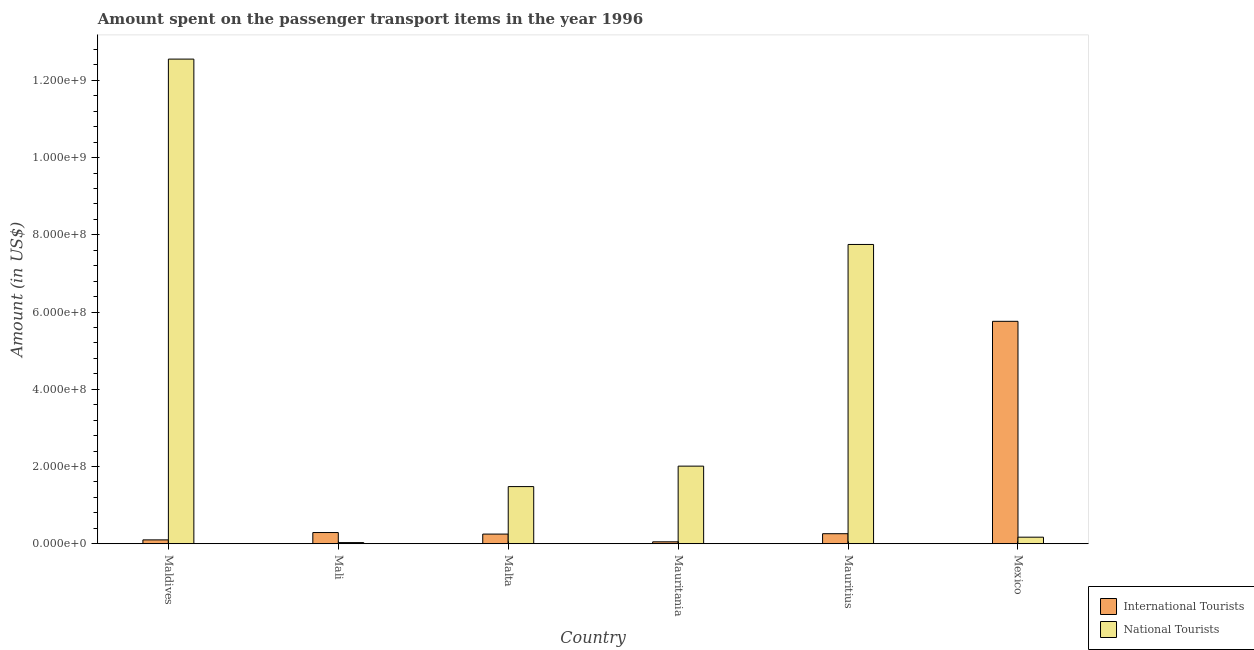How many bars are there on the 5th tick from the left?
Give a very brief answer. 2. How many bars are there on the 6th tick from the right?
Provide a succinct answer. 2. In how many cases, is the number of bars for a given country not equal to the number of legend labels?
Give a very brief answer. 0. What is the amount spent on transport items of international tourists in Mexico?
Your answer should be compact. 5.76e+08. Across all countries, what is the maximum amount spent on transport items of international tourists?
Provide a succinct answer. 5.76e+08. In which country was the amount spent on transport items of international tourists maximum?
Your response must be concise. Mexico. In which country was the amount spent on transport items of national tourists minimum?
Ensure brevity in your answer.  Mali. What is the total amount spent on transport items of international tourists in the graph?
Your response must be concise. 6.71e+08. What is the difference between the amount spent on transport items of national tourists in Maldives and that in Malta?
Provide a short and direct response. 1.11e+09. What is the difference between the amount spent on transport items of international tourists in Maldives and the amount spent on transport items of national tourists in Mauritius?
Keep it short and to the point. -7.65e+08. What is the average amount spent on transport items of international tourists per country?
Offer a very short reply. 1.12e+08. What is the difference between the amount spent on transport items of national tourists and amount spent on transport items of international tourists in Malta?
Make the answer very short. 1.23e+08. In how many countries, is the amount spent on transport items of international tourists greater than 200000000 US$?
Provide a succinct answer. 1. What is the ratio of the amount spent on transport items of international tourists in Maldives to that in Mexico?
Offer a terse response. 0.02. What is the difference between the highest and the second highest amount spent on transport items of national tourists?
Keep it short and to the point. 4.80e+08. What is the difference between the highest and the lowest amount spent on transport items of national tourists?
Offer a terse response. 1.25e+09. In how many countries, is the amount spent on transport items of national tourists greater than the average amount spent on transport items of national tourists taken over all countries?
Keep it short and to the point. 2. Is the sum of the amount spent on transport items of international tourists in Mali and Mexico greater than the maximum amount spent on transport items of national tourists across all countries?
Ensure brevity in your answer.  No. What does the 1st bar from the left in Mexico represents?
Ensure brevity in your answer.  International Tourists. What does the 1st bar from the right in Mauritania represents?
Give a very brief answer. National Tourists. How many bars are there?
Your response must be concise. 12. Are all the bars in the graph horizontal?
Ensure brevity in your answer.  No. How many countries are there in the graph?
Provide a short and direct response. 6. What is the difference between two consecutive major ticks on the Y-axis?
Your response must be concise. 2.00e+08. What is the title of the graph?
Provide a short and direct response. Amount spent on the passenger transport items in the year 1996. Does "Transport services" appear as one of the legend labels in the graph?
Ensure brevity in your answer.  No. What is the label or title of the X-axis?
Your answer should be very brief. Country. What is the Amount (in US$) of International Tourists in Maldives?
Keep it short and to the point. 1.00e+07. What is the Amount (in US$) in National Tourists in Maldives?
Your answer should be compact. 1.26e+09. What is the Amount (in US$) in International Tourists in Mali?
Your answer should be compact. 2.90e+07. What is the Amount (in US$) of National Tourists in Mali?
Give a very brief answer. 3.00e+06. What is the Amount (in US$) of International Tourists in Malta?
Make the answer very short. 2.50e+07. What is the Amount (in US$) of National Tourists in Malta?
Provide a short and direct response. 1.48e+08. What is the Amount (in US$) of National Tourists in Mauritania?
Your answer should be very brief. 2.01e+08. What is the Amount (in US$) of International Tourists in Mauritius?
Offer a very short reply. 2.60e+07. What is the Amount (in US$) in National Tourists in Mauritius?
Give a very brief answer. 7.75e+08. What is the Amount (in US$) of International Tourists in Mexico?
Your answer should be compact. 5.76e+08. What is the Amount (in US$) in National Tourists in Mexico?
Ensure brevity in your answer.  1.70e+07. Across all countries, what is the maximum Amount (in US$) in International Tourists?
Offer a terse response. 5.76e+08. Across all countries, what is the maximum Amount (in US$) of National Tourists?
Ensure brevity in your answer.  1.26e+09. Across all countries, what is the minimum Amount (in US$) of International Tourists?
Provide a succinct answer. 5.00e+06. Across all countries, what is the minimum Amount (in US$) in National Tourists?
Ensure brevity in your answer.  3.00e+06. What is the total Amount (in US$) in International Tourists in the graph?
Your response must be concise. 6.71e+08. What is the total Amount (in US$) in National Tourists in the graph?
Your response must be concise. 2.40e+09. What is the difference between the Amount (in US$) of International Tourists in Maldives and that in Mali?
Give a very brief answer. -1.90e+07. What is the difference between the Amount (in US$) of National Tourists in Maldives and that in Mali?
Ensure brevity in your answer.  1.25e+09. What is the difference between the Amount (in US$) in International Tourists in Maldives and that in Malta?
Give a very brief answer. -1.50e+07. What is the difference between the Amount (in US$) in National Tourists in Maldives and that in Malta?
Give a very brief answer. 1.11e+09. What is the difference between the Amount (in US$) of National Tourists in Maldives and that in Mauritania?
Keep it short and to the point. 1.05e+09. What is the difference between the Amount (in US$) in International Tourists in Maldives and that in Mauritius?
Your response must be concise. -1.60e+07. What is the difference between the Amount (in US$) of National Tourists in Maldives and that in Mauritius?
Keep it short and to the point. 4.80e+08. What is the difference between the Amount (in US$) of International Tourists in Maldives and that in Mexico?
Your response must be concise. -5.66e+08. What is the difference between the Amount (in US$) of National Tourists in Maldives and that in Mexico?
Provide a short and direct response. 1.24e+09. What is the difference between the Amount (in US$) in International Tourists in Mali and that in Malta?
Offer a terse response. 4.00e+06. What is the difference between the Amount (in US$) in National Tourists in Mali and that in Malta?
Provide a short and direct response. -1.45e+08. What is the difference between the Amount (in US$) of International Tourists in Mali and that in Mauritania?
Your response must be concise. 2.40e+07. What is the difference between the Amount (in US$) in National Tourists in Mali and that in Mauritania?
Ensure brevity in your answer.  -1.98e+08. What is the difference between the Amount (in US$) in National Tourists in Mali and that in Mauritius?
Make the answer very short. -7.72e+08. What is the difference between the Amount (in US$) in International Tourists in Mali and that in Mexico?
Offer a very short reply. -5.47e+08. What is the difference between the Amount (in US$) in National Tourists in Mali and that in Mexico?
Offer a terse response. -1.40e+07. What is the difference between the Amount (in US$) of National Tourists in Malta and that in Mauritania?
Give a very brief answer. -5.30e+07. What is the difference between the Amount (in US$) of International Tourists in Malta and that in Mauritius?
Provide a short and direct response. -1.00e+06. What is the difference between the Amount (in US$) in National Tourists in Malta and that in Mauritius?
Make the answer very short. -6.27e+08. What is the difference between the Amount (in US$) of International Tourists in Malta and that in Mexico?
Provide a succinct answer. -5.51e+08. What is the difference between the Amount (in US$) in National Tourists in Malta and that in Mexico?
Your answer should be compact. 1.31e+08. What is the difference between the Amount (in US$) of International Tourists in Mauritania and that in Mauritius?
Your answer should be compact. -2.10e+07. What is the difference between the Amount (in US$) in National Tourists in Mauritania and that in Mauritius?
Ensure brevity in your answer.  -5.74e+08. What is the difference between the Amount (in US$) in International Tourists in Mauritania and that in Mexico?
Your response must be concise. -5.71e+08. What is the difference between the Amount (in US$) of National Tourists in Mauritania and that in Mexico?
Your answer should be compact. 1.84e+08. What is the difference between the Amount (in US$) in International Tourists in Mauritius and that in Mexico?
Your answer should be compact. -5.50e+08. What is the difference between the Amount (in US$) of National Tourists in Mauritius and that in Mexico?
Offer a very short reply. 7.58e+08. What is the difference between the Amount (in US$) of International Tourists in Maldives and the Amount (in US$) of National Tourists in Malta?
Your response must be concise. -1.38e+08. What is the difference between the Amount (in US$) in International Tourists in Maldives and the Amount (in US$) in National Tourists in Mauritania?
Keep it short and to the point. -1.91e+08. What is the difference between the Amount (in US$) in International Tourists in Maldives and the Amount (in US$) in National Tourists in Mauritius?
Offer a terse response. -7.65e+08. What is the difference between the Amount (in US$) of International Tourists in Maldives and the Amount (in US$) of National Tourists in Mexico?
Give a very brief answer. -7.00e+06. What is the difference between the Amount (in US$) of International Tourists in Mali and the Amount (in US$) of National Tourists in Malta?
Your answer should be compact. -1.19e+08. What is the difference between the Amount (in US$) in International Tourists in Mali and the Amount (in US$) in National Tourists in Mauritania?
Keep it short and to the point. -1.72e+08. What is the difference between the Amount (in US$) in International Tourists in Mali and the Amount (in US$) in National Tourists in Mauritius?
Provide a succinct answer. -7.46e+08. What is the difference between the Amount (in US$) in International Tourists in Malta and the Amount (in US$) in National Tourists in Mauritania?
Provide a short and direct response. -1.76e+08. What is the difference between the Amount (in US$) of International Tourists in Malta and the Amount (in US$) of National Tourists in Mauritius?
Your answer should be very brief. -7.50e+08. What is the difference between the Amount (in US$) in International Tourists in Malta and the Amount (in US$) in National Tourists in Mexico?
Ensure brevity in your answer.  8.00e+06. What is the difference between the Amount (in US$) in International Tourists in Mauritania and the Amount (in US$) in National Tourists in Mauritius?
Keep it short and to the point. -7.70e+08. What is the difference between the Amount (in US$) in International Tourists in Mauritania and the Amount (in US$) in National Tourists in Mexico?
Make the answer very short. -1.20e+07. What is the difference between the Amount (in US$) in International Tourists in Mauritius and the Amount (in US$) in National Tourists in Mexico?
Your answer should be compact. 9.00e+06. What is the average Amount (in US$) of International Tourists per country?
Keep it short and to the point. 1.12e+08. What is the average Amount (in US$) of National Tourists per country?
Make the answer very short. 4.00e+08. What is the difference between the Amount (in US$) in International Tourists and Amount (in US$) in National Tourists in Maldives?
Your answer should be compact. -1.24e+09. What is the difference between the Amount (in US$) of International Tourists and Amount (in US$) of National Tourists in Mali?
Offer a terse response. 2.60e+07. What is the difference between the Amount (in US$) of International Tourists and Amount (in US$) of National Tourists in Malta?
Your response must be concise. -1.23e+08. What is the difference between the Amount (in US$) of International Tourists and Amount (in US$) of National Tourists in Mauritania?
Provide a succinct answer. -1.96e+08. What is the difference between the Amount (in US$) in International Tourists and Amount (in US$) in National Tourists in Mauritius?
Offer a terse response. -7.49e+08. What is the difference between the Amount (in US$) of International Tourists and Amount (in US$) of National Tourists in Mexico?
Offer a terse response. 5.59e+08. What is the ratio of the Amount (in US$) of International Tourists in Maldives to that in Mali?
Make the answer very short. 0.34. What is the ratio of the Amount (in US$) in National Tourists in Maldives to that in Mali?
Keep it short and to the point. 418.33. What is the ratio of the Amount (in US$) in International Tourists in Maldives to that in Malta?
Make the answer very short. 0.4. What is the ratio of the Amount (in US$) in National Tourists in Maldives to that in Malta?
Provide a short and direct response. 8.48. What is the ratio of the Amount (in US$) in National Tourists in Maldives to that in Mauritania?
Give a very brief answer. 6.24. What is the ratio of the Amount (in US$) in International Tourists in Maldives to that in Mauritius?
Offer a terse response. 0.38. What is the ratio of the Amount (in US$) of National Tourists in Maldives to that in Mauritius?
Keep it short and to the point. 1.62. What is the ratio of the Amount (in US$) of International Tourists in Maldives to that in Mexico?
Your answer should be compact. 0.02. What is the ratio of the Amount (in US$) of National Tourists in Maldives to that in Mexico?
Ensure brevity in your answer.  73.82. What is the ratio of the Amount (in US$) in International Tourists in Mali to that in Malta?
Offer a very short reply. 1.16. What is the ratio of the Amount (in US$) of National Tourists in Mali to that in Malta?
Your response must be concise. 0.02. What is the ratio of the Amount (in US$) in National Tourists in Mali to that in Mauritania?
Make the answer very short. 0.01. What is the ratio of the Amount (in US$) in International Tourists in Mali to that in Mauritius?
Your response must be concise. 1.12. What is the ratio of the Amount (in US$) of National Tourists in Mali to that in Mauritius?
Offer a very short reply. 0. What is the ratio of the Amount (in US$) in International Tourists in Mali to that in Mexico?
Ensure brevity in your answer.  0.05. What is the ratio of the Amount (in US$) of National Tourists in Mali to that in Mexico?
Give a very brief answer. 0.18. What is the ratio of the Amount (in US$) in National Tourists in Malta to that in Mauritania?
Keep it short and to the point. 0.74. What is the ratio of the Amount (in US$) in International Tourists in Malta to that in Mauritius?
Give a very brief answer. 0.96. What is the ratio of the Amount (in US$) in National Tourists in Malta to that in Mauritius?
Provide a succinct answer. 0.19. What is the ratio of the Amount (in US$) of International Tourists in Malta to that in Mexico?
Give a very brief answer. 0.04. What is the ratio of the Amount (in US$) of National Tourists in Malta to that in Mexico?
Provide a succinct answer. 8.71. What is the ratio of the Amount (in US$) in International Tourists in Mauritania to that in Mauritius?
Make the answer very short. 0.19. What is the ratio of the Amount (in US$) of National Tourists in Mauritania to that in Mauritius?
Offer a terse response. 0.26. What is the ratio of the Amount (in US$) of International Tourists in Mauritania to that in Mexico?
Provide a short and direct response. 0.01. What is the ratio of the Amount (in US$) in National Tourists in Mauritania to that in Mexico?
Provide a succinct answer. 11.82. What is the ratio of the Amount (in US$) of International Tourists in Mauritius to that in Mexico?
Provide a succinct answer. 0.05. What is the ratio of the Amount (in US$) of National Tourists in Mauritius to that in Mexico?
Provide a succinct answer. 45.59. What is the difference between the highest and the second highest Amount (in US$) in International Tourists?
Your answer should be compact. 5.47e+08. What is the difference between the highest and the second highest Amount (in US$) in National Tourists?
Provide a succinct answer. 4.80e+08. What is the difference between the highest and the lowest Amount (in US$) in International Tourists?
Your answer should be compact. 5.71e+08. What is the difference between the highest and the lowest Amount (in US$) in National Tourists?
Ensure brevity in your answer.  1.25e+09. 